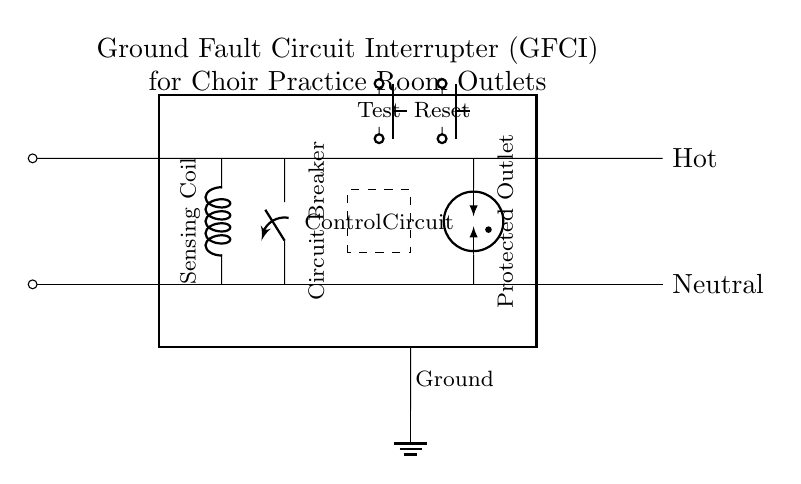What is the main function of the GFCI in this circuit? The Ground Fault Circuit Interrupter (GFCI) is designed to protect against electrical shock by detecting ground faults. It interrupts the circuit quickly if an imbalance of electrical current is detected between the hot and neutral wires.
Answer: Protect against electrical shock What type of component is used to sense current imbalances in this circuit? The component used to sense current imbalances is a sensing coil. This device detects when the current flowing through the hot wire does not match the current returning through the neutral wire, indicating a possible ground fault.
Answer: Sensing coil How many buttons are present in the circuit, and what are their functions? There are two buttons: one for testing the GFCI and another for resetting it. The test button simulates a ground fault to ensure the GFCI is functioning properly, while the reset button restores power after a trip.
Answer: Two buttons, test and reset What is the purpose of the circuit breaker in this diagram? The circuit breaker serves the function of stopping electrical flow in case of an overload or short circuit, providing safety by preventing potential fires or damage to the circuit.
Answer: Protect against overloads What is the significance of the ground connection in this circuit? The ground connection is crucial for safety; it provides a path for electric current to dissipate into the earth in case of a fault, significantly reducing the risk of electrical shock.
Answer: Safety path for current 